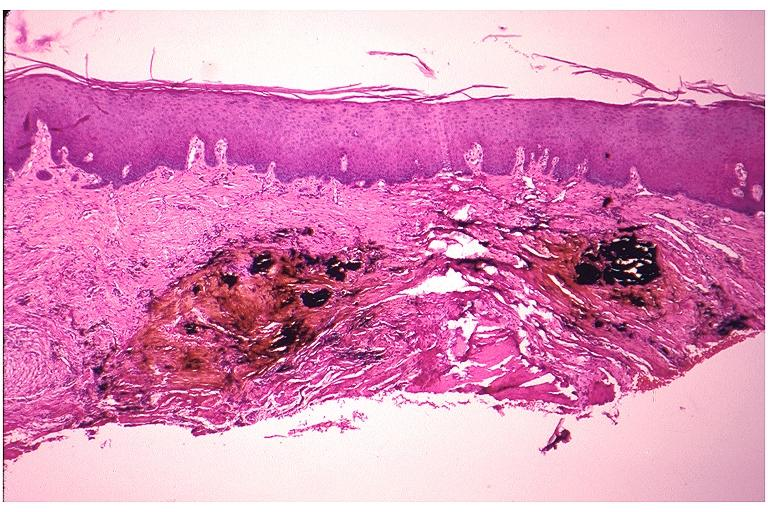s oral present?
Answer the question using a single word or phrase. Yes 